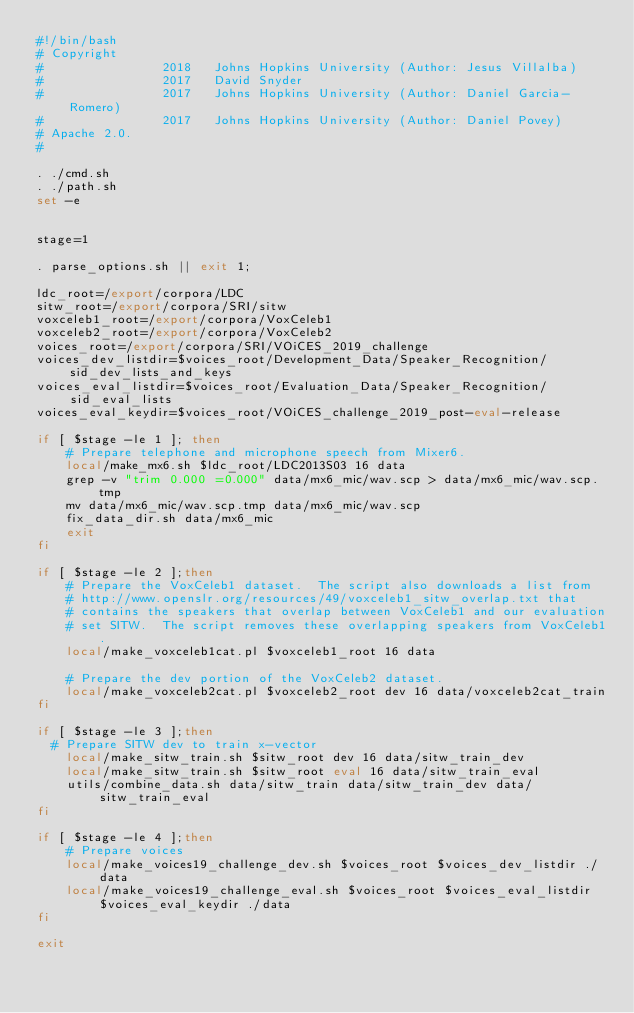Convert code to text. <code><loc_0><loc_0><loc_500><loc_500><_Bash_>#!/bin/bash
# Copyright
#                2018   Johns Hopkins University (Author: Jesus Villalba)
#                2017   David Snyder
#                2017   Johns Hopkins University (Author: Daniel Garcia-Romero)
#                2017   Johns Hopkins University (Author: Daniel Povey)
# Apache 2.0.
#

. ./cmd.sh
. ./path.sh
set -e


stage=1

. parse_options.sh || exit 1;

ldc_root=/export/corpora/LDC
sitw_root=/export/corpora/SRI/sitw
voxceleb1_root=/export/corpora/VoxCeleb1
voxceleb2_root=/export/corpora/VoxCeleb2
voices_root=/export/corpora/SRI/VOiCES_2019_challenge
voices_dev_listdir=$voices_root/Development_Data/Speaker_Recognition/sid_dev_lists_and_keys
voices_eval_listdir=$voices_root/Evaluation_Data/Speaker_Recognition/sid_eval_lists
voices_eval_keydir=$voices_root/VOiCES_challenge_2019_post-eval-release

if [ $stage -le 1 ]; then
    # Prepare telephone and microphone speech from Mixer6.
    local/make_mx6.sh $ldc_root/LDC2013S03 16 data
    grep -v "trim 0.000 =0.000" data/mx6_mic/wav.scp > data/mx6_mic/wav.scp.tmp
    mv data/mx6_mic/wav.scp.tmp data/mx6_mic/wav.scp
    fix_data_dir.sh data/mx6_mic
    exit
fi

if [ $stage -le 2 ];then
    # Prepare the VoxCeleb1 dataset.  The script also downloads a list from
    # http://www.openslr.org/resources/49/voxceleb1_sitw_overlap.txt that
    # contains the speakers that overlap between VoxCeleb1 and our evaluation
    # set SITW.  The script removes these overlapping speakers from VoxCeleb1.
    local/make_voxceleb1cat.pl $voxceleb1_root 16 data

    # Prepare the dev portion of the VoxCeleb2 dataset.
    local/make_voxceleb2cat.pl $voxceleb2_root dev 16 data/voxceleb2cat_train
fi

if [ $stage -le 3 ];then
  # Prepare SITW dev to train x-vector
    local/make_sitw_train.sh $sitw_root dev 16 data/sitw_train_dev
    local/make_sitw_train.sh $sitw_root eval 16 data/sitw_train_eval
    utils/combine_data.sh data/sitw_train data/sitw_train_dev data/sitw_train_eval
fi

if [ $stage -le 4 ];then
    # Prepare voices
    local/make_voices19_challenge_dev.sh $voices_root $voices_dev_listdir ./data
    local/make_voices19_challenge_eval.sh $voices_root $voices_eval_listdir $voices_eval_keydir ./data
fi

exit
</code> 